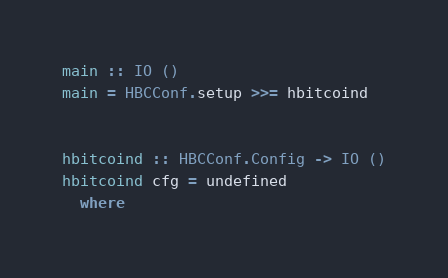<code> <loc_0><loc_0><loc_500><loc_500><_Haskell_>main :: IO ()
main = HBCConf.setup >>= hbitcoind

 
hbitcoind :: HBCConf.Config -> IO ()
hbitcoind cfg = undefined
  where
</code> 